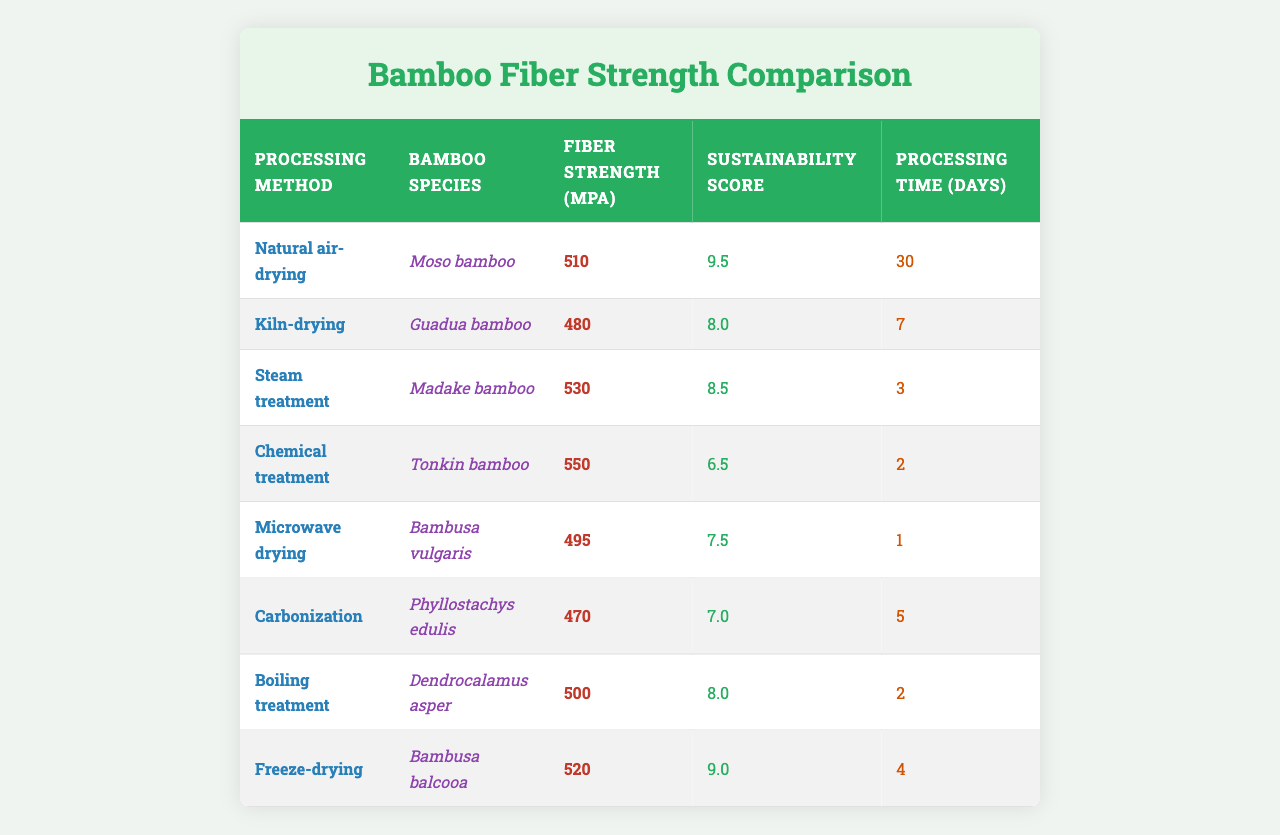What is the fiber strength of bamboo treated with chemical treatment? According to the table, the fiber strength for bamboo processed with chemical treatment is listed as 550 MPa.
Answer: 550 MPa Which bamboo species has the highest fiber strength? When examining the table, the maximum fiber strength recorded is for Tonkin bamboo at 550 MPa from chemical treatment.
Answer: Tonkin bamboo How long does it take to process bamboo using the microwave drying method? The processing time for bamboo using microwave drying is specified in the table as 1 day.
Answer: 1 day What is the sustainability score of the bamboo species used in steam treatment? The steam treatment process corresponds to Madake bamboo, which has a sustainability score of 8.5 as indicated in the table.
Answer: 8.5 Which processing method has the shortest processing time, and how long is it? The table shows that microwave drying has the shortest processing time of 1 day.
Answer: Microwave drying; 1 day What is the average fiber strength of bamboo processed by natural air-drying and boiling treatment? The fiber strengths for these methods are 510 MPa (natural air-drying) and 500 MPa (boiling treatment). The average is (510 + 500) / 2 = 505 MPa.
Answer: 505 MPa Is the fiber strength of bamboo from Guadua species processed by kiln-drying greater than that of bamboo from Phyllostachys edulis processed by carbonization? Guadua bamboo processed by kiln-drying has a fiber strength of 480 MPa, while Phyllostachys edulis processed by carbonization has 470 MPa. Since 480 MPa is greater than 470 MPa, the answer is yes.
Answer: Yes If we sum the sustainability scores of all methods, what is the total? The sustainability scores are 9.5 (natural air-drying), 8.0 (kiln-drying), 8.5 (steam treatment), 6.5 (chemical treatment), 7.5 (microwave drying), 7.0 (carbonization), 8.0 (boiling treatment), and 9.0 (freeze-drying). Adding these gives 9.5 + 8.0 + 8.5 + 6.5 + 7.5 + 7.0 + 8.0 + 9.0 = 64.0.
Answer: 64.0 Which bamboo species has a sustainability score of 7.0? The table states that the sustainability score of bamboo processed by carbonization is 7.0, which corresponds to Phyllostachys edulis.
Answer: Phyllostachys edulis What processing method has the highest fiber strength and how long does it take to process? The processing method with the highest fiber strength is chemical treatment at 550 MPa, and it has a processing time of 2 days.
Answer: Chemical treatment; 2 days 